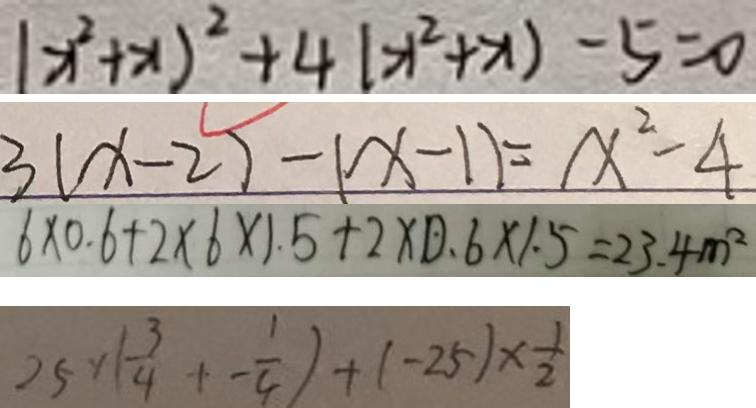Convert formula to latex. <formula><loc_0><loc_0><loc_500><loc_500>( x ^ { 2 } + x ) ^ { 2 } + 4 ( x ^ { 2 } + x ) - 5 = 0 
 3 ( x - 2 ) - ( x - 1 ) = x ^ { 2 } - 4 
 6 \times 0 . 6 + 2 \times 6 \times 1 . 5 + 2 \times 0 . 6 \times 1 . 5 = 2 3 . 4 m ^ { 2 } 
 2 5 \times ( \frac { 3 } { 4 } + - \frac { 1 } { 4 } ) + ( - 2 5 ) \times \frac { 1 } { 2 }</formula> 